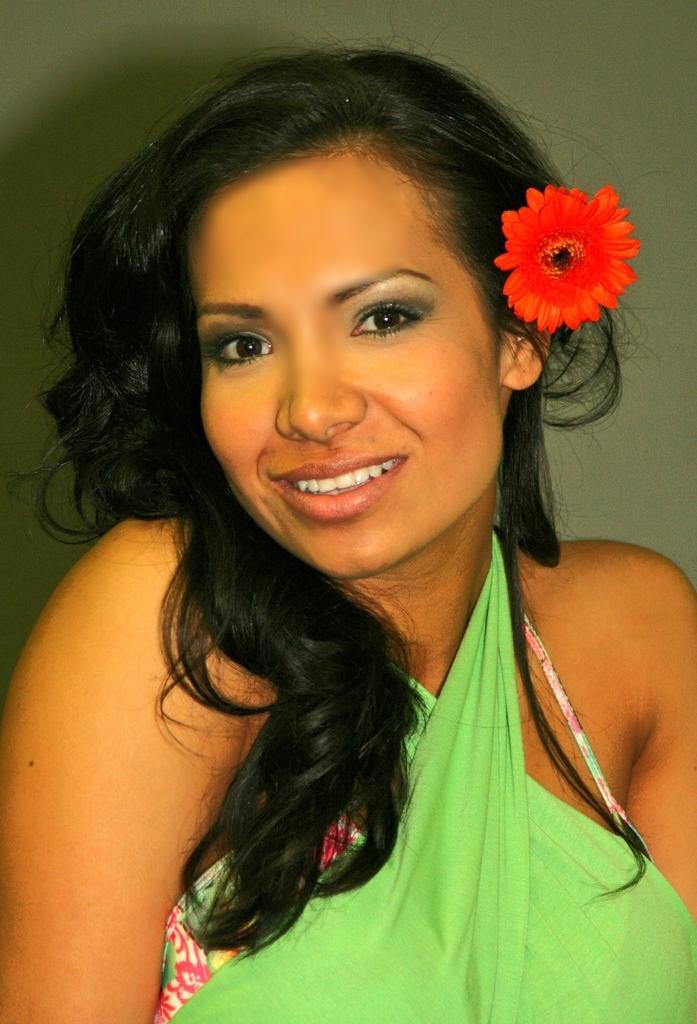Describe this image in one or two sentences. This image consists of a woman. She is wearing a green dress. She is smiling. She also has a flower in her hair. 